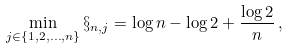<formula> <loc_0><loc_0><loc_500><loc_500>\min _ { j \in \{ 1 , 2 , \dots , n \} } \S _ { n , j } = \log n - \log 2 + \frac { \log 2 } { n } \, ,</formula> 